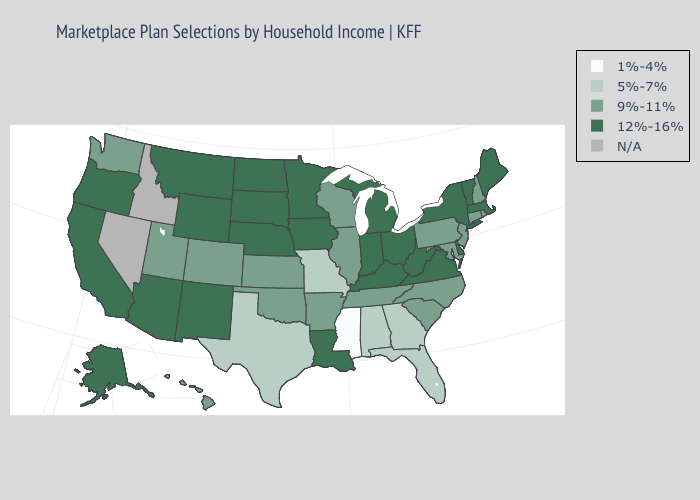Which states have the lowest value in the USA?
Quick response, please. Mississippi. Is the legend a continuous bar?
Keep it brief. No. Name the states that have a value in the range N/A?
Short answer required. Idaho, Nevada. Name the states that have a value in the range 5%-7%?
Give a very brief answer. Alabama, Florida, Georgia, Missouri, Texas. Does Massachusetts have the highest value in the Northeast?
Give a very brief answer. Yes. What is the highest value in states that border Indiana?
Be succinct. 12%-16%. Name the states that have a value in the range 5%-7%?
Quick response, please. Alabama, Florida, Georgia, Missouri, Texas. What is the value of New Jersey?
Concise answer only. 9%-11%. What is the highest value in states that border Ohio?
Quick response, please. 12%-16%. Does New York have the highest value in the Northeast?
Answer briefly. Yes. Name the states that have a value in the range 12%-16%?
Concise answer only. Alaska, Arizona, California, Delaware, Indiana, Iowa, Kentucky, Louisiana, Maine, Massachusetts, Michigan, Minnesota, Montana, Nebraska, New Mexico, New York, North Dakota, Ohio, Oregon, South Dakota, Vermont, Virginia, West Virginia, Wyoming. What is the value of Pennsylvania?
Answer briefly. 9%-11%. Does Mississippi have the lowest value in the USA?
Concise answer only. Yes. Which states have the lowest value in the USA?
Give a very brief answer. Mississippi. 